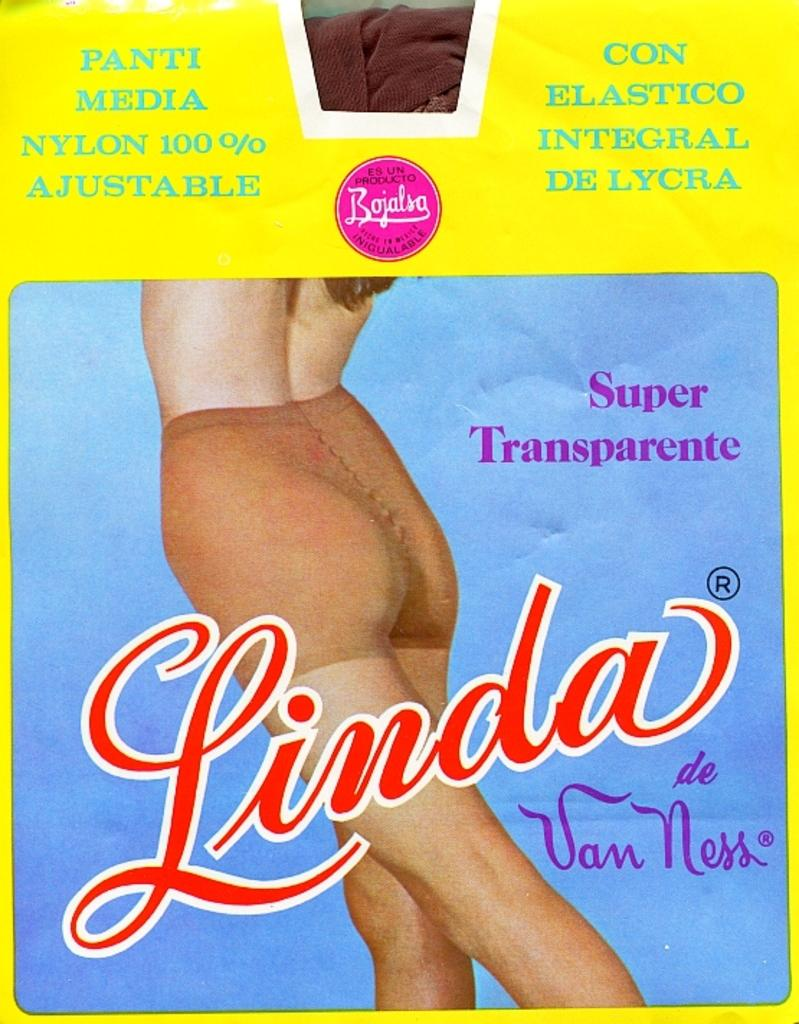What can be seen in the foreground of the poster? There is text and an image of a person in the foreground of the poster. What type of treatment is being offered in the bedroom depicted in the image? There is no bedroom or treatment present in the image; it only features text and an image of a person in the foreground of the poster. 